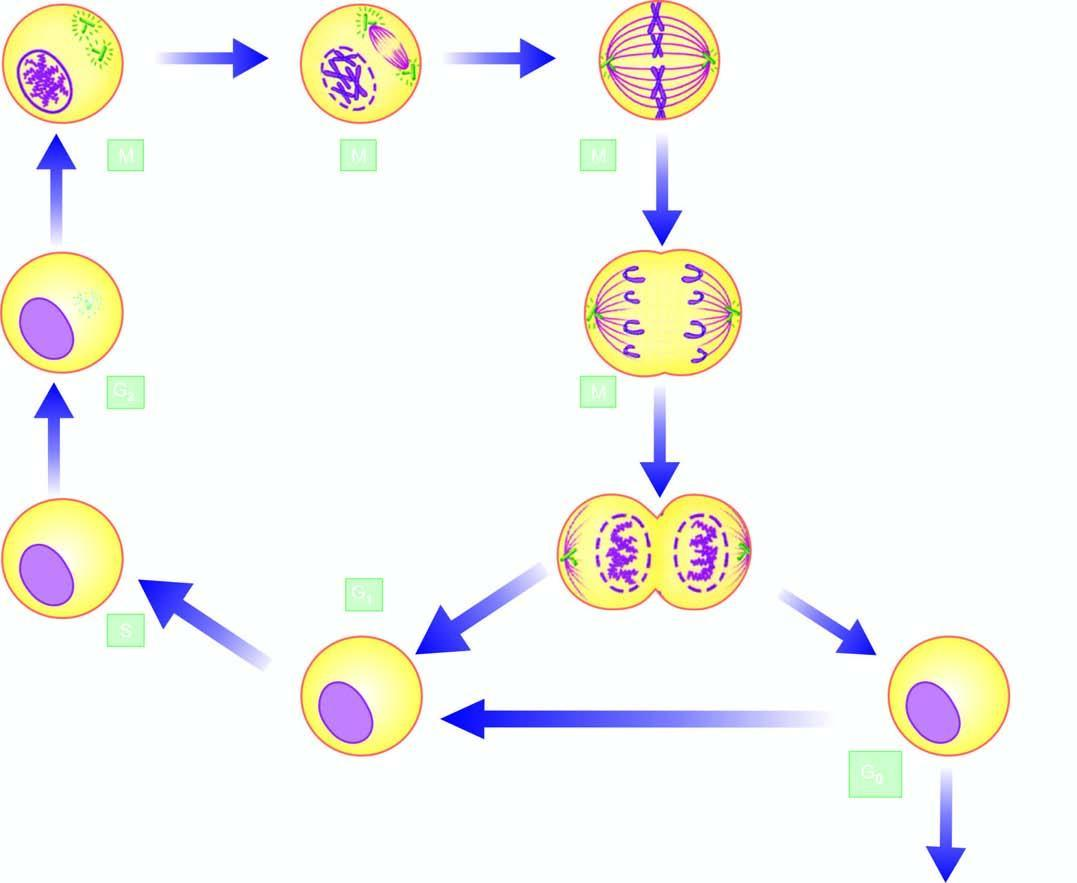what is accomplished in 4 sequential stages: prophase, metaphase, anaphase, and telophase?
Answer the question using a single word or phrase. M (mitotic) telophase 